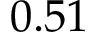<formula> <loc_0><loc_0><loc_500><loc_500>0 . 5 1</formula> 